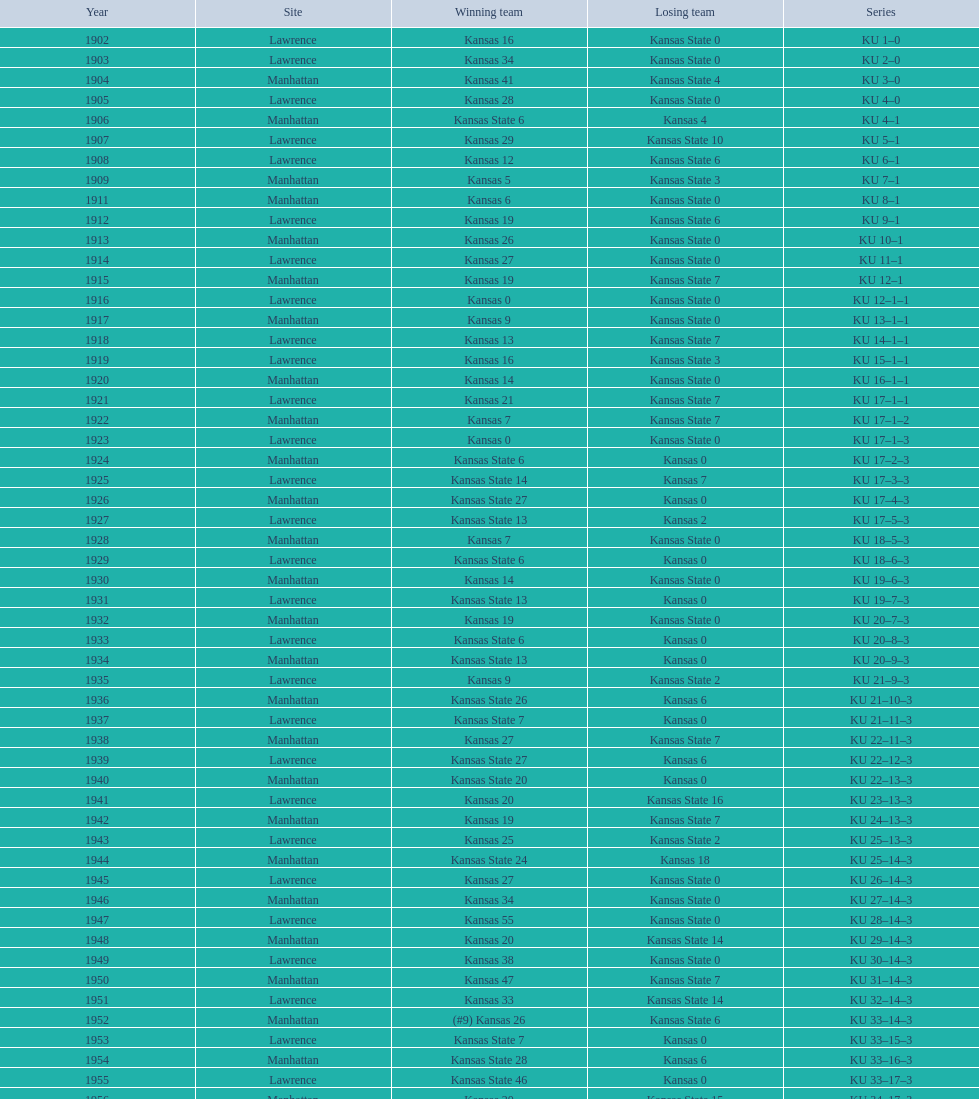Before 1910, how many times did kansas triumph over kansas state? 7. 